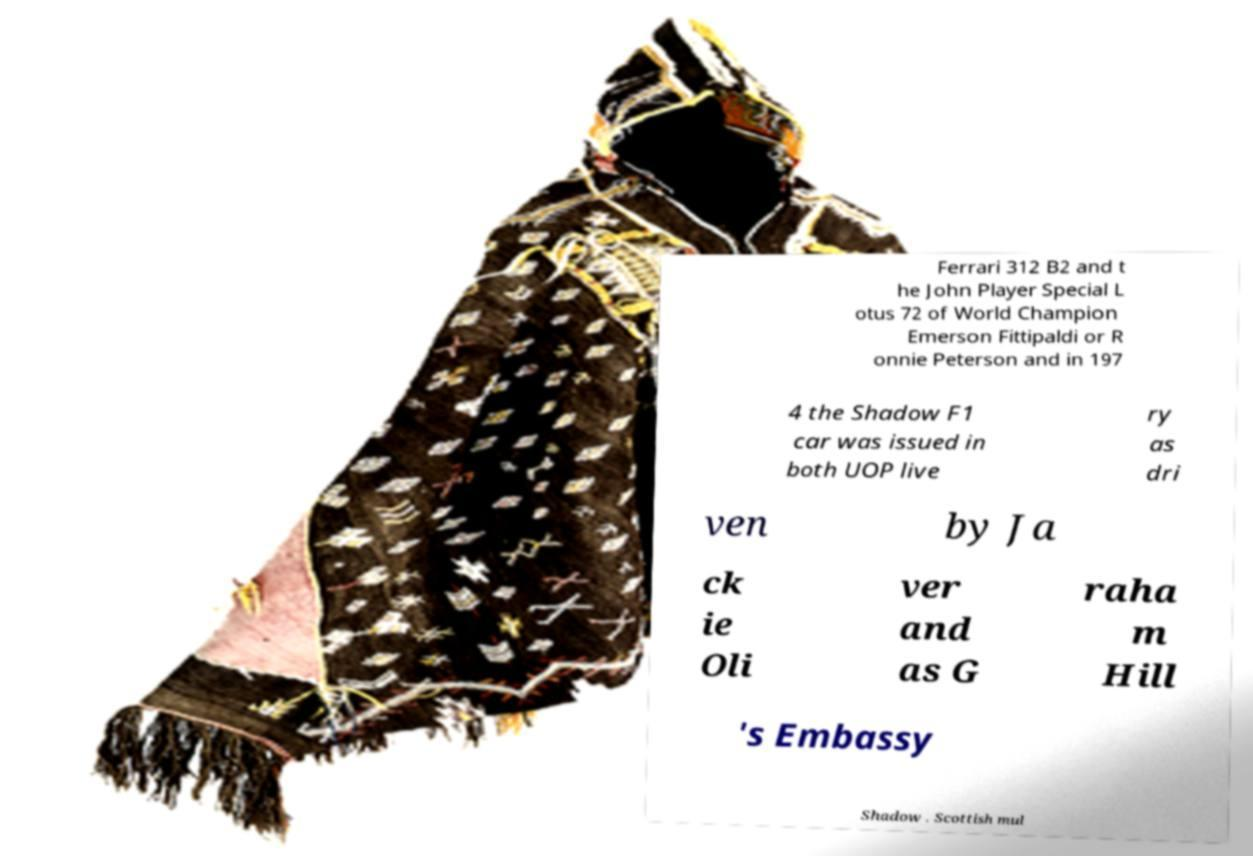For documentation purposes, I need the text within this image transcribed. Could you provide that? Ferrari 312 B2 and t he John Player Special L otus 72 of World Champion Emerson Fittipaldi or R onnie Peterson and in 197 4 the Shadow F1 car was issued in both UOP live ry as dri ven by Ja ck ie Oli ver and as G raha m Hill 's Embassy Shadow . Scottish mul 